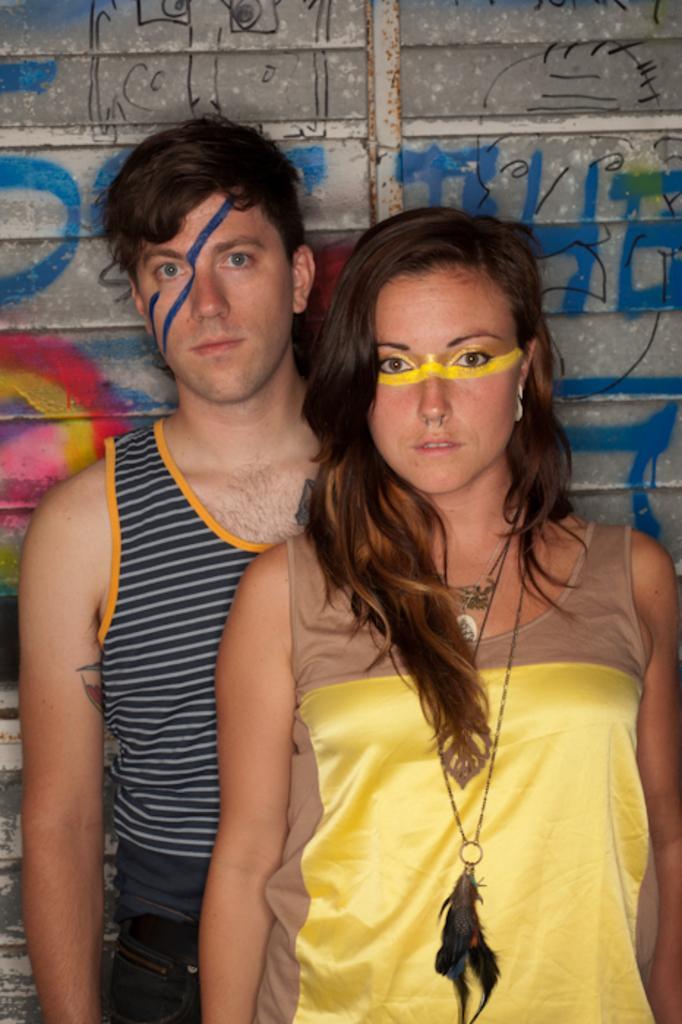Please provide a concise description of this image. In the picture we can see a man and a woman standing near the wall, the woman is wearing a yellow dress with a tag in her neck, and a man is wearing a blue top with lines on it and some colored lined on their faces. 